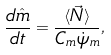Convert formula to latex. <formula><loc_0><loc_0><loc_500><loc_500>\frac { d { \hat { m } } } { d t } = \frac { \langle \vec { N } \rangle } { C _ { m } \dot { \psi } _ { m } } ,</formula> 